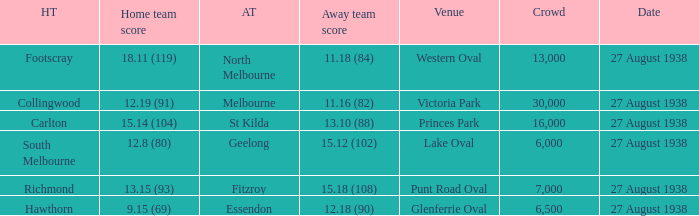How many people witnessed their home team score 13.15 (93)? 7000.0. 